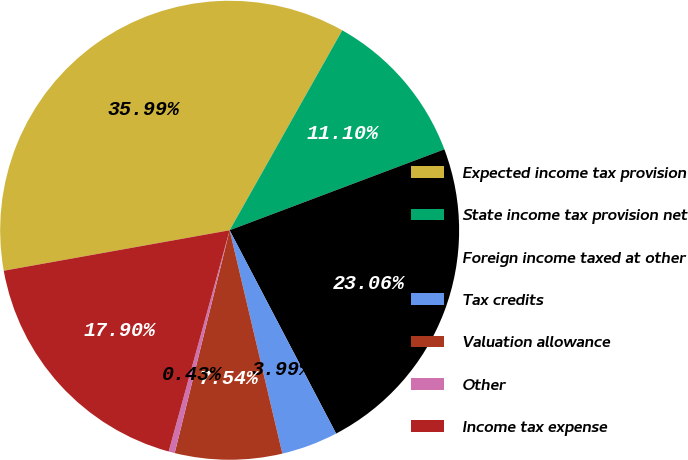<chart> <loc_0><loc_0><loc_500><loc_500><pie_chart><fcel>Expected income tax provision<fcel>State income tax provision net<fcel>Foreign income taxed at other<fcel>Tax credits<fcel>Valuation allowance<fcel>Other<fcel>Income tax expense<nl><fcel>35.99%<fcel>11.1%<fcel>23.06%<fcel>3.99%<fcel>7.54%<fcel>0.43%<fcel>17.9%<nl></chart> 